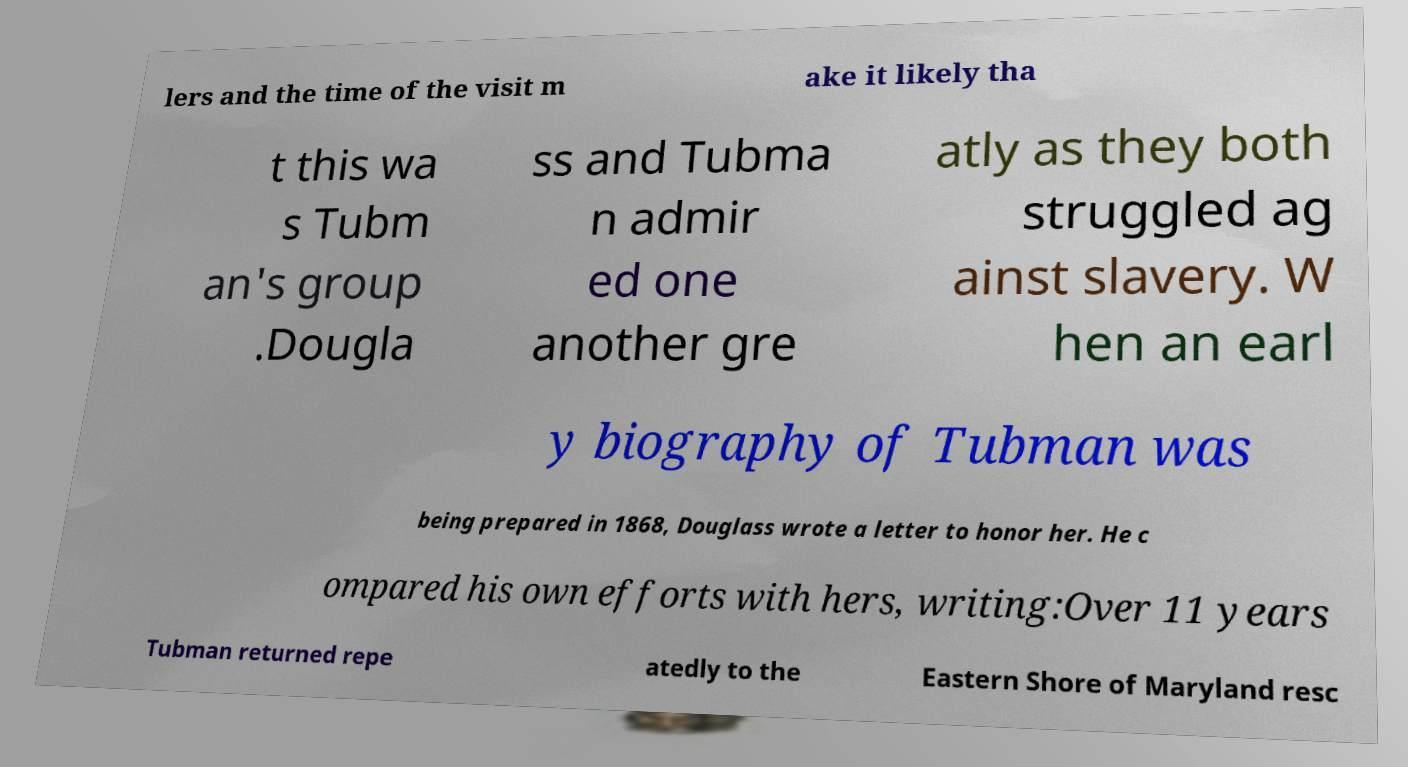Can you accurately transcribe the text from the provided image for me? lers and the time of the visit m ake it likely tha t this wa s Tubm an's group .Dougla ss and Tubma n admir ed one another gre atly as they both struggled ag ainst slavery. W hen an earl y biography of Tubman was being prepared in 1868, Douglass wrote a letter to honor her. He c ompared his own efforts with hers, writing:Over 11 years Tubman returned repe atedly to the Eastern Shore of Maryland resc 